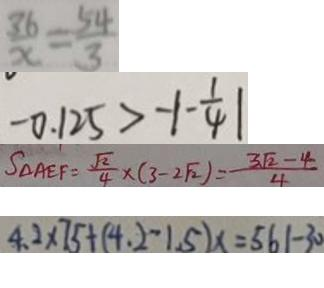Convert formula to latex. <formula><loc_0><loc_0><loc_500><loc_500>\frac { 3 6 } { x } = \frac { 5 4 } { 3 } 
 - 0 . 1 2 5 > - \vert - \frac { 1 } { 4 } \vert 
 S _ { \Delta A E F } = \frac { \sqrt { 2 } } { 4 } \times ( 3 - 2 \sqrt { 2 } ) = \frac { 3 \sqrt { 2 } - 4 } { 4 } 
 4 . 2 \times 7 5 + ( 4 . 2 - 1 . 5 ) x = 5 6 1 - 3 0</formula> 